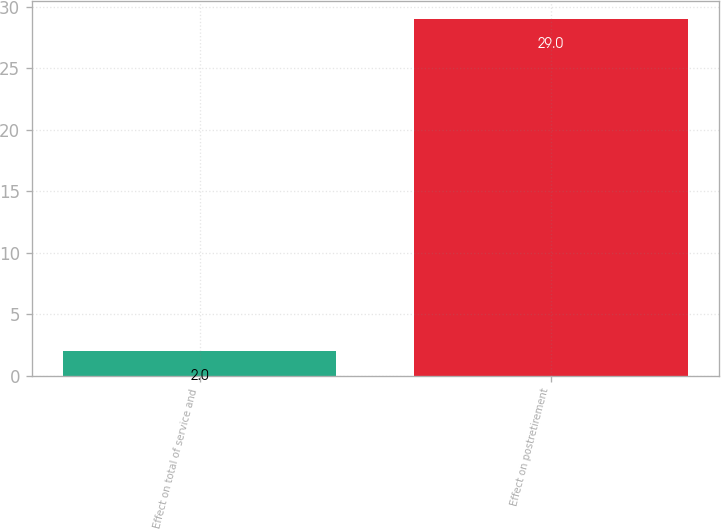Convert chart. <chart><loc_0><loc_0><loc_500><loc_500><bar_chart><fcel>Effect on total of service and<fcel>Effect on postretirement<nl><fcel>2<fcel>29<nl></chart> 